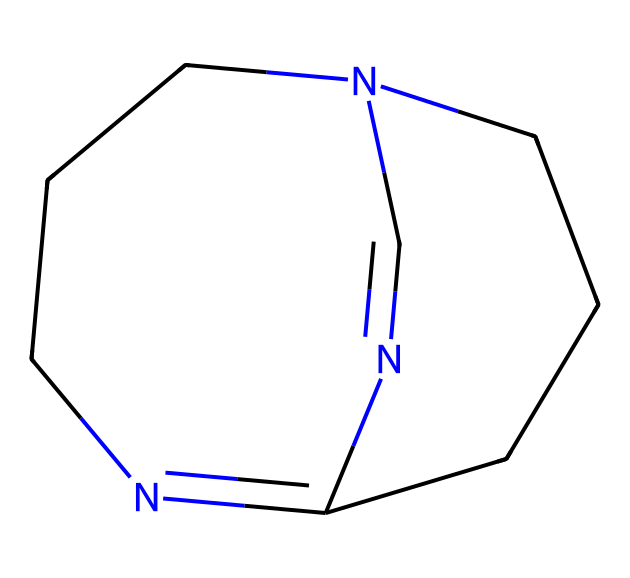What is the molecular formula of 1,8-diazabicyclo[5.4.0]undec-7-ene? By analyzing the SMILES representation, I count the number of carbon (C), hydrogen (H), and nitrogen (N) atoms. The structure shows 11 carbons, 12 hydrogens, and 2 nitrogens. The molecular formula combines these counts: C11H12N2.
Answer: C11H12N2 How many nitrogen atoms are present in the molecule? The SMILES representation indicates the presence of two nitrogen atoms as shown by 'N' appearances.
Answer: 2 What type of bonds are present in this superbase? The chemical structure contains both single and double bonds, characterized by the alternating lines connecting atoms. Each bond is visually represented in the structure.
Answer: single and double Does this compound act as a strong base? DBU is classified as a superbasic compound due to the presence of nitrogen atoms in its structure, allowing for strong proton acceptance. Thus, it acts as a strong base.
Answer: yes What type of cyclic structure does 1,8-diazabicyclo[5.4.0]undec-7-ene have? The name indicates a bicyclic structure, which is confirmed by the two interconnected rings in the molecular structure. Bicyclic compounds are identified by having two cycles.
Answer: bicyclic What properties do nitrogen atoms impart to this superbase? The nitrogen atoms in this superbase contribute to increased basicity and stability, as their lone pairs allow for proton acceptance, and this is a key characteristic of superbases.
Answer: increased basicity 